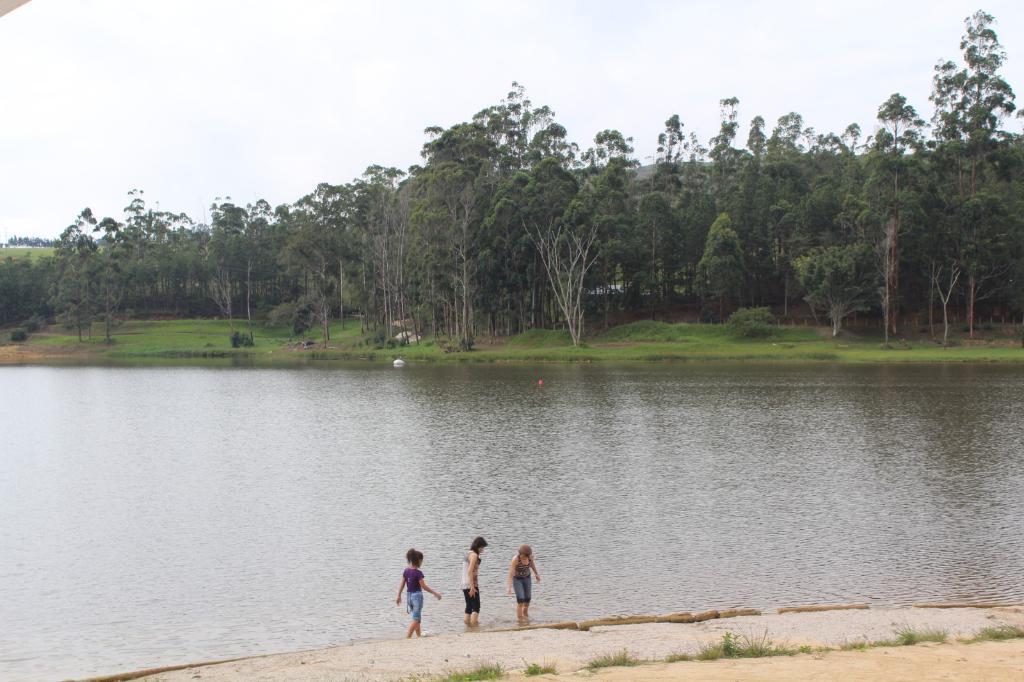In one or two sentences, can you explain what this image depicts? In the center of the image water is present. In the background of the image trees and grass are there. At the bottom of the image three ladies are standing. At the bottom right corner soil is present. At the top of the image sky is present. 